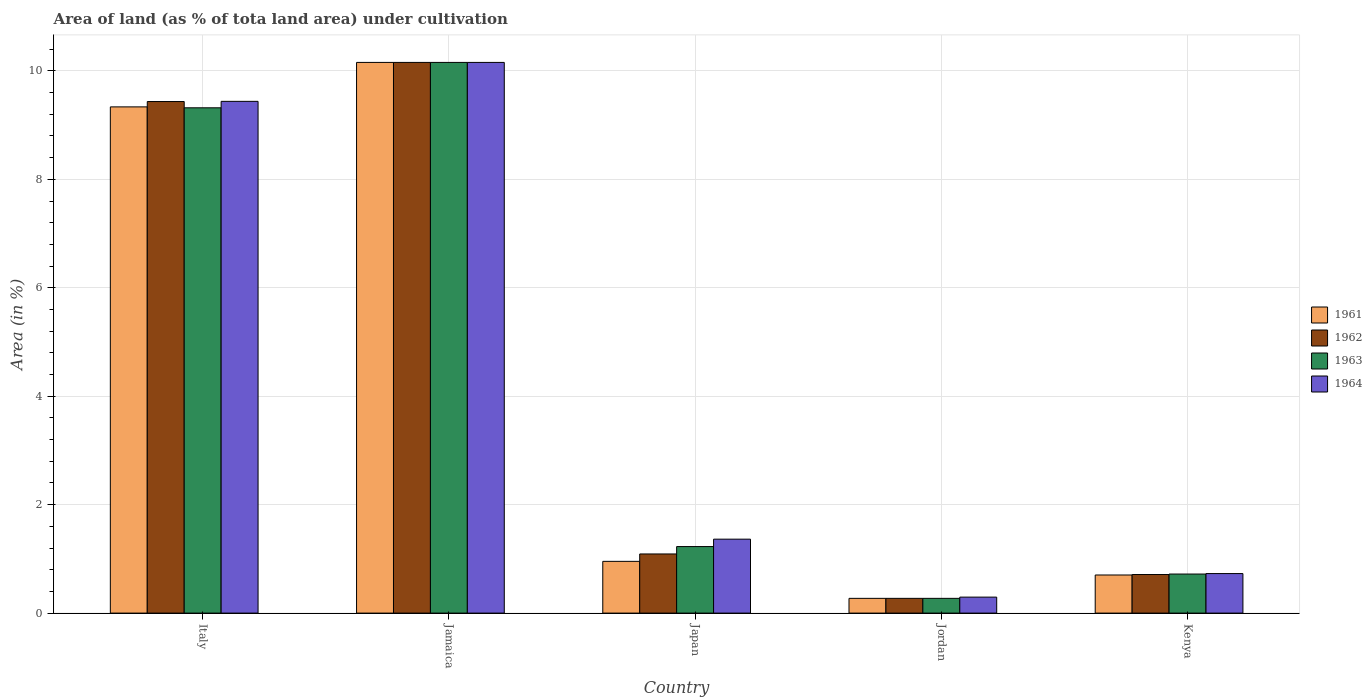How many different coloured bars are there?
Ensure brevity in your answer.  4. How many groups of bars are there?
Provide a short and direct response. 5. Are the number of bars per tick equal to the number of legend labels?
Keep it short and to the point. Yes. Are the number of bars on each tick of the X-axis equal?
Ensure brevity in your answer.  Yes. How many bars are there on the 4th tick from the left?
Offer a terse response. 4. What is the label of the 2nd group of bars from the left?
Provide a succinct answer. Jamaica. In how many cases, is the number of bars for a given country not equal to the number of legend labels?
Provide a short and direct response. 0. What is the percentage of land under cultivation in 1964 in Italy?
Provide a succinct answer. 9.44. Across all countries, what is the maximum percentage of land under cultivation in 1961?
Give a very brief answer. 10.16. Across all countries, what is the minimum percentage of land under cultivation in 1962?
Keep it short and to the point. 0.27. In which country was the percentage of land under cultivation in 1963 maximum?
Keep it short and to the point. Jamaica. In which country was the percentage of land under cultivation in 1961 minimum?
Your answer should be compact. Jordan. What is the total percentage of land under cultivation in 1961 in the graph?
Offer a very short reply. 21.42. What is the difference between the percentage of land under cultivation in 1963 in Italy and that in Japan?
Make the answer very short. 8.09. What is the difference between the percentage of land under cultivation in 1962 in Jamaica and the percentage of land under cultivation in 1963 in Jordan?
Offer a terse response. 9.88. What is the average percentage of land under cultivation in 1962 per country?
Your response must be concise. 4.33. What is the difference between the percentage of land under cultivation of/in 1962 and percentage of land under cultivation of/in 1964 in Jamaica?
Keep it short and to the point. 0. What is the ratio of the percentage of land under cultivation in 1963 in Italy to that in Kenya?
Provide a succinct answer. 12.94. What is the difference between the highest and the second highest percentage of land under cultivation in 1961?
Make the answer very short. -8.38. What is the difference between the highest and the lowest percentage of land under cultivation in 1963?
Offer a very short reply. 9.88. Is the sum of the percentage of land under cultivation in 1963 in Jordan and Kenya greater than the maximum percentage of land under cultivation in 1962 across all countries?
Ensure brevity in your answer.  No. What does the 4th bar from the left in Italy represents?
Offer a very short reply. 1964. Is it the case that in every country, the sum of the percentage of land under cultivation in 1962 and percentage of land under cultivation in 1961 is greater than the percentage of land under cultivation in 1964?
Your answer should be very brief. Yes. Are the values on the major ticks of Y-axis written in scientific E-notation?
Offer a very short reply. No. Where does the legend appear in the graph?
Offer a very short reply. Center right. What is the title of the graph?
Your response must be concise. Area of land (as % of tota land area) under cultivation. Does "1980" appear as one of the legend labels in the graph?
Keep it short and to the point. No. What is the label or title of the Y-axis?
Ensure brevity in your answer.  Area (in %). What is the Area (in %) of 1961 in Italy?
Offer a very short reply. 9.34. What is the Area (in %) of 1962 in Italy?
Offer a very short reply. 9.44. What is the Area (in %) of 1963 in Italy?
Your response must be concise. 9.32. What is the Area (in %) in 1964 in Italy?
Your answer should be very brief. 9.44. What is the Area (in %) in 1961 in Jamaica?
Offer a very short reply. 10.16. What is the Area (in %) of 1962 in Jamaica?
Ensure brevity in your answer.  10.16. What is the Area (in %) of 1963 in Jamaica?
Your response must be concise. 10.16. What is the Area (in %) in 1964 in Jamaica?
Your answer should be compact. 10.16. What is the Area (in %) in 1961 in Japan?
Offer a terse response. 0.95. What is the Area (in %) in 1962 in Japan?
Your answer should be very brief. 1.09. What is the Area (in %) of 1963 in Japan?
Your answer should be very brief. 1.23. What is the Area (in %) of 1964 in Japan?
Ensure brevity in your answer.  1.36. What is the Area (in %) in 1961 in Jordan?
Your answer should be compact. 0.27. What is the Area (in %) of 1962 in Jordan?
Your answer should be compact. 0.27. What is the Area (in %) in 1963 in Jordan?
Provide a short and direct response. 0.27. What is the Area (in %) in 1964 in Jordan?
Provide a succinct answer. 0.29. What is the Area (in %) in 1961 in Kenya?
Provide a succinct answer. 0.7. What is the Area (in %) in 1962 in Kenya?
Your answer should be very brief. 0.71. What is the Area (in %) in 1963 in Kenya?
Your answer should be very brief. 0.72. What is the Area (in %) of 1964 in Kenya?
Make the answer very short. 0.73. Across all countries, what is the maximum Area (in %) in 1961?
Make the answer very short. 10.16. Across all countries, what is the maximum Area (in %) in 1962?
Keep it short and to the point. 10.16. Across all countries, what is the maximum Area (in %) of 1963?
Your response must be concise. 10.16. Across all countries, what is the maximum Area (in %) of 1964?
Offer a very short reply. 10.16. Across all countries, what is the minimum Area (in %) of 1961?
Offer a very short reply. 0.27. Across all countries, what is the minimum Area (in %) of 1962?
Give a very brief answer. 0.27. Across all countries, what is the minimum Area (in %) of 1963?
Ensure brevity in your answer.  0.27. Across all countries, what is the minimum Area (in %) of 1964?
Provide a succinct answer. 0.29. What is the total Area (in %) in 1961 in the graph?
Provide a succinct answer. 21.42. What is the total Area (in %) in 1962 in the graph?
Your answer should be compact. 21.67. What is the total Area (in %) in 1963 in the graph?
Provide a succinct answer. 21.7. What is the total Area (in %) of 1964 in the graph?
Offer a terse response. 21.98. What is the difference between the Area (in %) of 1961 in Italy and that in Jamaica?
Your answer should be very brief. -0.82. What is the difference between the Area (in %) of 1962 in Italy and that in Jamaica?
Your answer should be very brief. -0.72. What is the difference between the Area (in %) of 1963 in Italy and that in Jamaica?
Provide a short and direct response. -0.84. What is the difference between the Area (in %) in 1964 in Italy and that in Jamaica?
Your response must be concise. -0.72. What is the difference between the Area (in %) in 1961 in Italy and that in Japan?
Provide a short and direct response. 8.38. What is the difference between the Area (in %) of 1962 in Italy and that in Japan?
Provide a short and direct response. 8.34. What is the difference between the Area (in %) in 1963 in Italy and that in Japan?
Provide a succinct answer. 8.09. What is the difference between the Area (in %) of 1964 in Italy and that in Japan?
Offer a terse response. 8.08. What is the difference between the Area (in %) of 1961 in Italy and that in Jordan?
Make the answer very short. 9.06. What is the difference between the Area (in %) of 1962 in Italy and that in Jordan?
Keep it short and to the point. 9.16. What is the difference between the Area (in %) in 1963 in Italy and that in Jordan?
Your answer should be compact. 9.05. What is the difference between the Area (in %) in 1964 in Italy and that in Jordan?
Provide a short and direct response. 9.14. What is the difference between the Area (in %) of 1961 in Italy and that in Kenya?
Offer a terse response. 8.63. What is the difference between the Area (in %) of 1962 in Italy and that in Kenya?
Provide a short and direct response. 8.72. What is the difference between the Area (in %) of 1963 in Italy and that in Kenya?
Your answer should be compact. 8.6. What is the difference between the Area (in %) of 1964 in Italy and that in Kenya?
Offer a terse response. 8.71. What is the difference between the Area (in %) in 1961 in Jamaica and that in Japan?
Your answer should be very brief. 9.2. What is the difference between the Area (in %) of 1962 in Jamaica and that in Japan?
Provide a succinct answer. 9.07. What is the difference between the Area (in %) in 1963 in Jamaica and that in Japan?
Keep it short and to the point. 8.93. What is the difference between the Area (in %) of 1964 in Jamaica and that in Japan?
Give a very brief answer. 8.79. What is the difference between the Area (in %) of 1961 in Jamaica and that in Jordan?
Give a very brief answer. 9.88. What is the difference between the Area (in %) of 1962 in Jamaica and that in Jordan?
Give a very brief answer. 9.88. What is the difference between the Area (in %) of 1963 in Jamaica and that in Jordan?
Make the answer very short. 9.88. What is the difference between the Area (in %) in 1964 in Jamaica and that in Jordan?
Keep it short and to the point. 9.86. What is the difference between the Area (in %) in 1961 in Jamaica and that in Kenya?
Your answer should be compact. 9.45. What is the difference between the Area (in %) in 1962 in Jamaica and that in Kenya?
Offer a terse response. 9.45. What is the difference between the Area (in %) of 1963 in Jamaica and that in Kenya?
Provide a short and direct response. 9.44. What is the difference between the Area (in %) in 1964 in Jamaica and that in Kenya?
Make the answer very short. 9.43. What is the difference between the Area (in %) in 1961 in Japan and that in Jordan?
Offer a very short reply. 0.68. What is the difference between the Area (in %) of 1962 in Japan and that in Jordan?
Your answer should be very brief. 0.82. What is the difference between the Area (in %) of 1963 in Japan and that in Jordan?
Your response must be concise. 0.96. What is the difference between the Area (in %) in 1964 in Japan and that in Jordan?
Provide a short and direct response. 1.07. What is the difference between the Area (in %) in 1961 in Japan and that in Kenya?
Offer a terse response. 0.25. What is the difference between the Area (in %) in 1962 in Japan and that in Kenya?
Make the answer very short. 0.38. What is the difference between the Area (in %) in 1963 in Japan and that in Kenya?
Your answer should be compact. 0.51. What is the difference between the Area (in %) of 1964 in Japan and that in Kenya?
Make the answer very short. 0.63. What is the difference between the Area (in %) of 1961 in Jordan and that in Kenya?
Give a very brief answer. -0.43. What is the difference between the Area (in %) of 1962 in Jordan and that in Kenya?
Make the answer very short. -0.44. What is the difference between the Area (in %) of 1963 in Jordan and that in Kenya?
Make the answer very short. -0.45. What is the difference between the Area (in %) of 1964 in Jordan and that in Kenya?
Your answer should be compact. -0.43. What is the difference between the Area (in %) in 1961 in Italy and the Area (in %) in 1962 in Jamaica?
Keep it short and to the point. -0.82. What is the difference between the Area (in %) in 1961 in Italy and the Area (in %) in 1963 in Jamaica?
Give a very brief answer. -0.82. What is the difference between the Area (in %) of 1961 in Italy and the Area (in %) of 1964 in Jamaica?
Provide a short and direct response. -0.82. What is the difference between the Area (in %) in 1962 in Italy and the Area (in %) in 1963 in Jamaica?
Offer a very short reply. -0.72. What is the difference between the Area (in %) of 1962 in Italy and the Area (in %) of 1964 in Jamaica?
Make the answer very short. -0.72. What is the difference between the Area (in %) of 1963 in Italy and the Area (in %) of 1964 in Jamaica?
Give a very brief answer. -0.84. What is the difference between the Area (in %) in 1961 in Italy and the Area (in %) in 1962 in Japan?
Offer a very short reply. 8.25. What is the difference between the Area (in %) of 1961 in Italy and the Area (in %) of 1963 in Japan?
Your answer should be very brief. 8.11. What is the difference between the Area (in %) of 1961 in Italy and the Area (in %) of 1964 in Japan?
Provide a short and direct response. 7.97. What is the difference between the Area (in %) in 1962 in Italy and the Area (in %) in 1963 in Japan?
Your response must be concise. 8.21. What is the difference between the Area (in %) of 1962 in Italy and the Area (in %) of 1964 in Japan?
Your answer should be very brief. 8.07. What is the difference between the Area (in %) in 1963 in Italy and the Area (in %) in 1964 in Japan?
Your answer should be compact. 7.96. What is the difference between the Area (in %) in 1961 in Italy and the Area (in %) in 1962 in Jordan?
Make the answer very short. 9.06. What is the difference between the Area (in %) of 1961 in Italy and the Area (in %) of 1963 in Jordan?
Provide a short and direct response. 9.06. What is the difference between the Area (in %) in 1961 in Italy and the Area (in %) in 1964 in Jordan?
Your response must be concise. 9.04. What is the difference between the Area (in %) of 1962 in Italy and the Area (in %) of 1963 in Jordan?
Ensure brevity in your answer.  9.16. What is the difference between the Area (in %) in 1962 in Italy and the Area (in %) in 1964 in Jordan?
Give a very brief answer. 9.14. What is the difference between the Area (in %) in 1963 in Italy and the Area (in %) in 1964 in Jordan?
Ensure brevity in your answer.  9.03. What is the difference between the Area (in %) of 1961 in Italy and the Area (in %) of 1962 in Kenya?
Offer a very short reply. 8.62. What is the difference between the Area (in %) in 1961 in Italy and the Area (in %) in 1963 in Kenya?
Make the answer very short. 8.62. What is the difference between the Area (in %) in 1961 in Italy and the Area (in %) in 1964 in Kenya?
Your response must be concise. 8.61. What is the difference between the Area (in %) in 1962 in Italy and the Area (in %) in 1963 in Kenya?
Your answer should be compact. 8.71. What is the difference between the Area (in %) of 1962 in Italy and the Area (in %) of 1964 in Kenya?
Give a very brief answer. 8.71. What is the difference between the Area (in %) in 1963 in Italy and the Area (in %) in 1964 in Kenya?
Your response must be concise. 8.59. What is the difference between the Area (in %) in 1961 in Jamaica and the Area (in %) in 1962 in Japan?
Provide a succinct answer. 9.07. What is the difference between the Area (in %) in 1961 in Jamaica and the Area (in %) in 1963 in Japan?
Your answer should be compact. 8.93. What is the difference between the Area (in %) in 1961 in Jamaica and the Area (in %) in 1964 in Japan?
Keep it short and to the point. 8.79. What is the difference between the Area (in %) of 1962 in Jamaica and the Area (in %) of 1963 in Japan?
Offer a terse response. 8.93. What is the difference between the Area (in %) in 1962 in Jamaica and the Area (in %) in 1964 in Japan?
Offer a terse response. 8.79. What is the difference between the Area (in %) of 1963 in Jamaica and the Area (in %) of 1964 in Japan?
Your answer should be very brief. 8.79. What is the difference between the Area (in %) of 1961 in Jamaica and the Area (in %) of 1962 in Jordan?
Your answer should be compact. 9.88. What is the difference between the Area (in %) in 1961 in Jamaica and the Area (in %) in 1963 in Jordan?
Give a very brief answer. 9.88. What is the difference between the Area (in %) in 1961 in Jamaica and the Area (in %) in 1964 in Jordan?
Offer a terse response. 9.86. What is the difference between the Area (in %) in 1962 in Jamaica and the Area (in %) in 1963 in Jordan?
Offer a very short reply. 9.88. What is the difference between the Area (in %) in 1962 in Jamaica and the Area (in %) in 1964 in Jordan?
Your answer should be very brief. 9.86. What is the difference between the Area (in %) in 1963 in Jamaica and the Area (in %) in 1964 in Jordan?
Offer a terse response. 9.86. What is the difference between the Area (in %) of 1961 in Jamaica and the Area (in %) of 1962 in Kenya?
Make the answer very short. 9.45. What is the difference between the Area (in %) of 1961 in Jamaica and the Area (in %) of 1963 in Kenya?
Offer a terse response. 9.44. What is the difference between the Area (in %) in 1961 in Jamaica and the Area (in %) in 1964 in Kenya?
Ensure brevity in your answer.  9.43. What is the difference between the Area (in %) of 1962 in Jamaica and the Area (in %) of 1963 in Kenya?
Your answer should be very brief. 9.44. What is the difference between the Area (in %) of 1962 in Jamaica and the Area (in %) of 1964 in Kenya?
Ensure brevity in your answer.  9.43. What is the difference between the Area (in %) in 1963 in Jamaica and the Area (in %) in 1964 in Kenya?
Your answer should be very brief. 9.43. What is the difference between the Area (in %) in 1961 in Japan and the Area (in %) in 1962 in Jordan?
Provide a succinct answer. 0.68. What is the difference between the Area (in %) of 1961 in Japan and the Area (in %) of 1963 in Jordan?
Ensure brevity in your answer.  0.68. What is the difference between the Area (in %) of 1961 in Japan and the Area (in %) of 1964 in Jordan?
Offer a very short reply. 0.66. What is the difference between the Area (in %) in 1962 in Japan and the Area (in %) in 1963 in Jordan?
Give a very brief answer. 0.82. What is the difference between the Area (in %) of 1962 in Japan and the Area (in %) of 1964 in Jordan?
Your answer should be very brief. 0.8. What is the difference between the Area (in %) in 1963 in Japan and the Area (in %) in 1964 in Jordan?
Offer a very short reply. 0.93. What is the difference between the Area (in %) of 1961 in Japan and the Area (in %) of 1962 in Kenya?
Your answer should be compact. 0.24. What is the difference between the Area (in %) of 1961 in Japan and the Area (in %) of 1963 in Kenya?
Your response must be concise. 0.23. What is the difference between the Area (in %) of 1961 in Japan and the Area (in %) of 1964 in Kenya?
Offer a very short reply. 0.23. What is the difference between the Area (in %) in 1962 in Japan and the Area (in %) in 1963 in Kenya?
Make the answer very short. 0.37. What is the difference between the Area (in %) of 1962 in Japan and the Area (in %) of 1964 in Kenya?
Your response must be concise. 0.36. What is the difference between the Area (in %) in 1963 in Japan and the Area (in %) in 1964 in Kenya?
Your answer should be very brief. 0.5. What is the difference between the Area (in %) of 1961 in Jordan and the Area (in %) of 1962 in Kenya?
Make the answer very short. -0.44. What is the difference between the Area (in %) of 1961 in Jordan and the Area (in %) of 1963 in Kenya?
Your answer should be very brief. -0.45. What is the difference between the Area (in %) in 1961 in Jordan and the Area (in %) in 1964 in Kenya?
Offer a terse response. -0.46. What is the difference between the Area (in %) in 1962 in Jordan and the Area (in %) in 1963 in Kenya?
Offer a very short reply. -0.45. What is the difference between the Area (in %) of 1962 in Jordan and the Area (in %) of 1964 in Kenya?
Offer a very short reply. -0.46. What is the difference between the Area (in %) of 1963 in Jordan and the Area (in %) of 1964 in Kenya?
Give a very brief answer. -0.46. What is the average Area (in %) of 1961 per country?
Make the answer very short. 4.28. What is the average Area (in %) in 1962 per country?
Offer a terse response. 4.33. What is the average Area (in %) of 1963 per country?
Provide a succinct answer. 4.34. What is the average Area (in %) of 1964 per country?
Your response must be concise. 4.4. What is the difference between the Area (in %) in 1961 and Area (in %) in 1962 in Italy?
Make the answer very short. -0.1. What is the difference between the Area (in %) of 1961 and Area (in %) of 1963 in Italy?
Provide a succinct answer. 0.02. What is the difference between the Area (in %) of 1961 and Area (in %) of 1964 in Italy?
Make the answer very short. -0.1. What is the difference between the Area (in %) of 1962 and Area (in %) of 1963 in Italy?
Keep it short and to the point. 0.12. What is the difference between the Area (in %) of 1962 and Area (in %) of 1964 in Italy?
Your answer should be very brief. -0. What is the difference between the Area (in %) of 1963 and Area (in %) of 1964 in Italy?
Your response must be concise. -0.12. What is the difference between the Area (in %) of 1961 and Area (in %) of 1962 in Jamaica?
Give a very brief answer. 0. What is the difference between the Area (in %) of 1961 and Area (in %) of 1963 in Jamaica?
Offer a very short reply. 0. What is the difference between the Area (in %) of 1961 and Area (in %) of 1964 in Jamaica?
Provide a succinct answer. 0. What is the difference between the Area (in %) in 1961 and Area (in %) in 1962 in Japan?
Your answer should be very brief. -0.14. What is the difference between the Area (in %) in 1961 and Area (in %) in 1963 in Japan?
Make the answer very short. -0.27. What is the difference between the Area (in %) in 1961 and Area (in %) in 1964 in Japan?
Ensure brevity in your answer.  -0.41. What is the difference between the Area (in %) of 1962 and Area (in %) of 1963 in Japan?
Your response must be concise. -0.14. What is the difference between the Area (in %) of 1962 and Area (in %) of 1964 in Japan?
Give a very brief answer. -0.27. What is the difference between the Area (in %) in 1963 and Area (in %) in 1964 in Japan?
Provide a succinct answer. -0.14. What is the difference between the Area (in %) in 1961 and Area (in %) in 1962 in Jordan?
Ensure brevity in your answer.  0. What is the difference between the Area (in %) of 1961 and Area (in %) of 1964 in Jordan?
Give a very brief answer. -0.02. What is the difference between the Area (in %) of 1962 and Area (in %) of 1964 in Jordan?
Keep it short and to the point. -0.02. What is the difference between the Area (in %) of 1963 and Area (in %) of 1964 in Jordan?
Provide a succinct answer. -0.02. What is the difference between the Area (in %) of 1961 and Area (in %) of 1962 in Kenya?
Your response must be concise. -0.01. What is the difference between the Area (in %) of 1961 and Area (in %) of 1963 in Kenya?
Your answer should be very brief. -0.02. What is the difference between the Area (in %) of 1961 and Area (in %) of 1964 in Kenya?
Your response must be concise. -0.03. What is the difference between the Area (in %) in 1962 and Area (in %) in 1963 in Kenya?
Your answer should be very brief. -0.01. What is the difference between the Area (in %) in 1962 and Area (in %) in 1964 in Kenya?
Ensure brevity in your answer.  -0.02. What is the difference between the Area (in %) in 1963 and Area (in %) in 1964 in Kenya?
Give a very brief answer. -0.01. What is the ratio of the Area (in %) in 1961 in Italy to that in Jamaica?
Your answer should be very brief. 0.92. What is the ratio of the Area (in %) in 1962 in Italy to that in Jamaica?
Give a very brief answer. 0.93. What is the ratio of the Area (in %) of 1963 in Italy to that in Jamaica?
Your answer should be very brief. 0.92. What is the ratio of the Area (in %) in 1964 in Italy to that in Jamaica?
Your answer should be very brief. 0.93. What is the ratio of the Area (in %) of 1961 in Italy to that in Japan?
Keep it short and to the point. 9.78. What is the ratio of the Area (in %) in 1962 in Italy to that in Japan?
Make the answer very short. 8.65. What is the ratio of the Area (in %) in 1963 in Italy to that in Japan?
Your response must be concise. 7.59. What is the ratio of the Area (in %) in 1964 in Italy to that in Japan?
Your response must be concise. 6.92. What is the ratio of the Area (in %) of 1961 in Italy to that in Jordan?
Offer a terse response. 34.33. What is the ratio of the Area (in %) in 1962 in Italy to that in Jordan?
Your answer should be compact. 34.69. What is the ratio of the Area (in %) of 1963 in Italy to that in Jordan?
Ensure brevity in your answer.  34.27. What is the ratio of the Area (in %) of 1964 in Italy to that in Jordan?
Give a very brief answer. 32.03. What is the ratio of the Area (in %) of 1961 in Italy to that in Kenya?
Provide a succinct answer. 13.28. What is the ratio of the Area (in %) of 1962 in Italy to that in Kenya?
Make the answer very short. 13.26. What is the ratio of the Area (in %) in 1963 in Italy to that in Kenya?
Give a very brief answer. 12.94. What is the ratio of the Area (in %) in 1964 in Italy to that in Kenya?
Your response must be concise. 12.94. What is the ratio of the Area (in %) of 1961 in Jamaica to that in Japan?
Your answer should be very brief. 10.64. What is the ratio of the Area (in %) of 1962 in Jamaica to that in Japan?
Your response must be concise. 9.31. What is the ratio of the Area (in %) of 1963 in Jamaica to that in Japan?
Ensure brevity in your answer.  8.28. What is the ratio of the Area (in %) of 1964 in Jamaica to that in Japan?
Your response must be concise. 7.45. What is the ratio of the Area (in %) of 1961 in Jamaica to that in Jordan?
Your response must be concise. 37.34. What is the ratio of the Area (in %) in 1962 in Jamaica to that in Jordan?
Provide a short and direct response. 37.34. What is the ratio of the Area (in %) of 1963 in Jamaica to that in Jordan?
Keep it short and to the point. 37.34. What is the ratio of the Area (in %) of 1964 in Jamaica to that in Jordan?
Your answer should be compact. 34.47. What is the ratio of the Area (in %) of 1961 in Jamaica to that in Kenya?
Offer a terse response. 14.45. What is the ratio of the Area (in %) in 1962 in Jamaica to that in Kenya?
Your response must be concise. 14.27. What is the ratio of the Area (in %) in 1963 in Jamaica to that in Kenya?
Keep it short and to the point. 14.1. What is the ratio of the Area (in %) in 1964 in Jamaica to that in Kenya?
Offer a terse response. 13.93. What is the ratio of the Area (in %) of 1961 in Japan to that in Jordan?
Your answer should be compact. 3.51. What is the ratio of the Area (in %) in 1962 in Japan to that in Jordan?
Provide a succinct answer. 4.01. What is the ratio of the Area (in %) of 1963 in Japan to that in Jordan?
Make the answer very short. 4.51. What is the ratio of the Area (in %) of 1964 in Japan to that in Jordan?
Make the answer very short. 4.63. What is the ratio of the Area (in %) of 1961 in Japan to that in Kenya?
Your response must be concise. 1.36. What is the ratio of the Area (in %) of 1962 in Japan to that in Kenya?
Provide a succinct answer. 1.53. What is the ratio of the Area (in %) of 1963 in Japan to that in Kenya?
Provide a short and direct response. 1.7. What is the ratio of the Area (in %) of 1964 in Japan to that in Kenya?
Your answer should be compact. 1.87. What is the ratio of the Area (in %) of 1961 in Jordan to that in Kenya?
Your answer should be very brief. 0.39. What is the ratio of the Area (in %) in 1962 in Jordan to that in Kenya?
Offer a very short reply. 0.38. What is the ratio of the Area (in %) in 1963 in Jordan to that in Kenya?
Your response must be concise. 0.38. What is the ratio of the Area (in %) of 1964 in Jordan to that in Kenya?
Provide a succinct answer. 0.4. What is the difference between the highest and the second highest Area (in %) in 1961?
Your answer should be very brief. 0.82. What is the difference between the highest and the second highest Area (in %) of 1962?
Ensure brevity in your answer.  0.72. What is the difference between the highest and the second highest Area (in %) in 1963?
Provide a succinct answer. 0.84. What is the difference between the highest and the second highest Area (in %) of 1964?
Your answer should be compact. 0.72. What is the difference between the highest and the lowest Area (in %) in 1961?
Ensure brevity in your answer.  9.88. What is the difference between the highest and the lowest Area (in %) of 1962?
Make the answer very short. 9.88. What is the difference between the highest and the lowest Area (in %) in 1963?
Provide a succinct answer. 9.88. What is the difference between the highest and the lowest Area (in %) in 1964?
Make the answer very short. 9.86. 